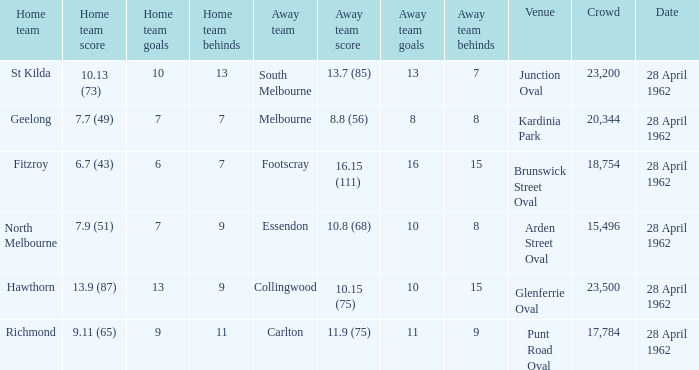What away team played at Brunswick Street Oval? Footscray. Could you parse the entire table? {'header': ['Home team', 'Home team score', 'Home team goals', 'Home team behinds', 'Away team', 'Away team score', 'Away team goals', 'Away team behinds', 'Venue', 'Crowd', 'Date'], 'rows': [['St Kilda', '10.13 (73)', '10', '13', 'South Melbourne', '13.7 (85)', '13', '7', 'Junction Oval', '23,200', '28 April 1962'], ['Geelong', '7.7 (49)', '7', '7', 'Melbourne', '8.8 (56)', '8', '8', 'Kardinia Park', '20,344', '28 April 1962'], ['Fitzroy', '6.7 (43)', '6', '7', 'Footscray', '16.15 (111)', '16', '15', 'Brunswick Street Oval', '18,754', '28 April 1962'], ['North Melbourne', '7.9 (51)', '7', '9', 'Essendon', '10.8 (68)', '10', '8', 'Arden Street Oval', '15,496', '28 April 1962'], ['Hawthorn', '13.9 (87)', '13', '9', 'Collingwood', '10.15 (75)', '10', '15', 'Glenferrie Oval', '23,500', '28 April 1962'], ['Richmond', '9.11 (65)', '9', '11', 'Carlton', '11.9 (75)', '11', '9', 'Punt Road Oval', '17,784', '28 April 1962']]} 